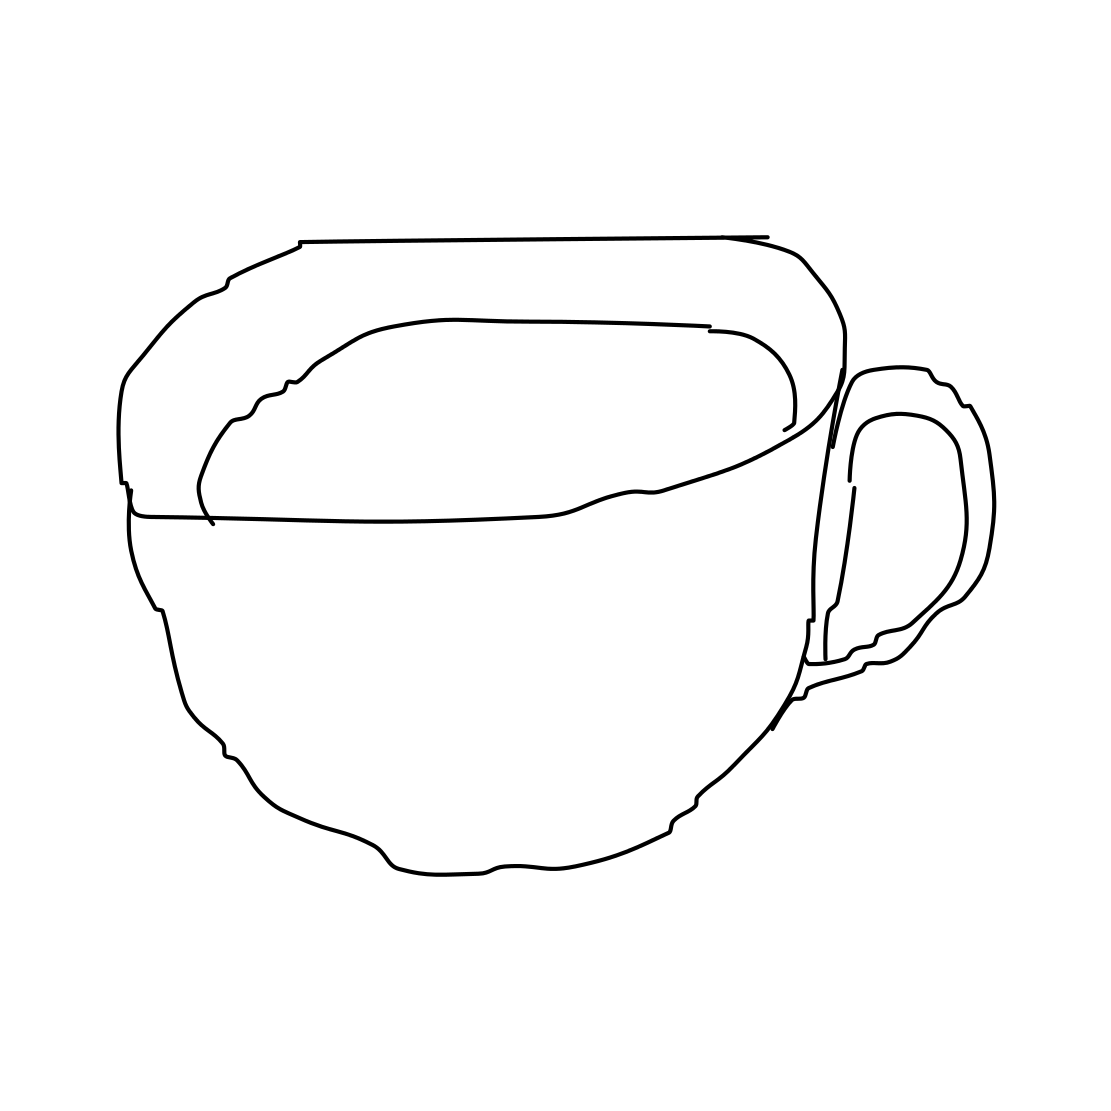Is this a cloud in the image? No 